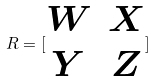Convert formula to latex. <formula><loc_0><loc_0><loc_500><loc_500>R = [ \begin{matrix} W & X \\ Y & Z \end{matrix} ]</formula> 